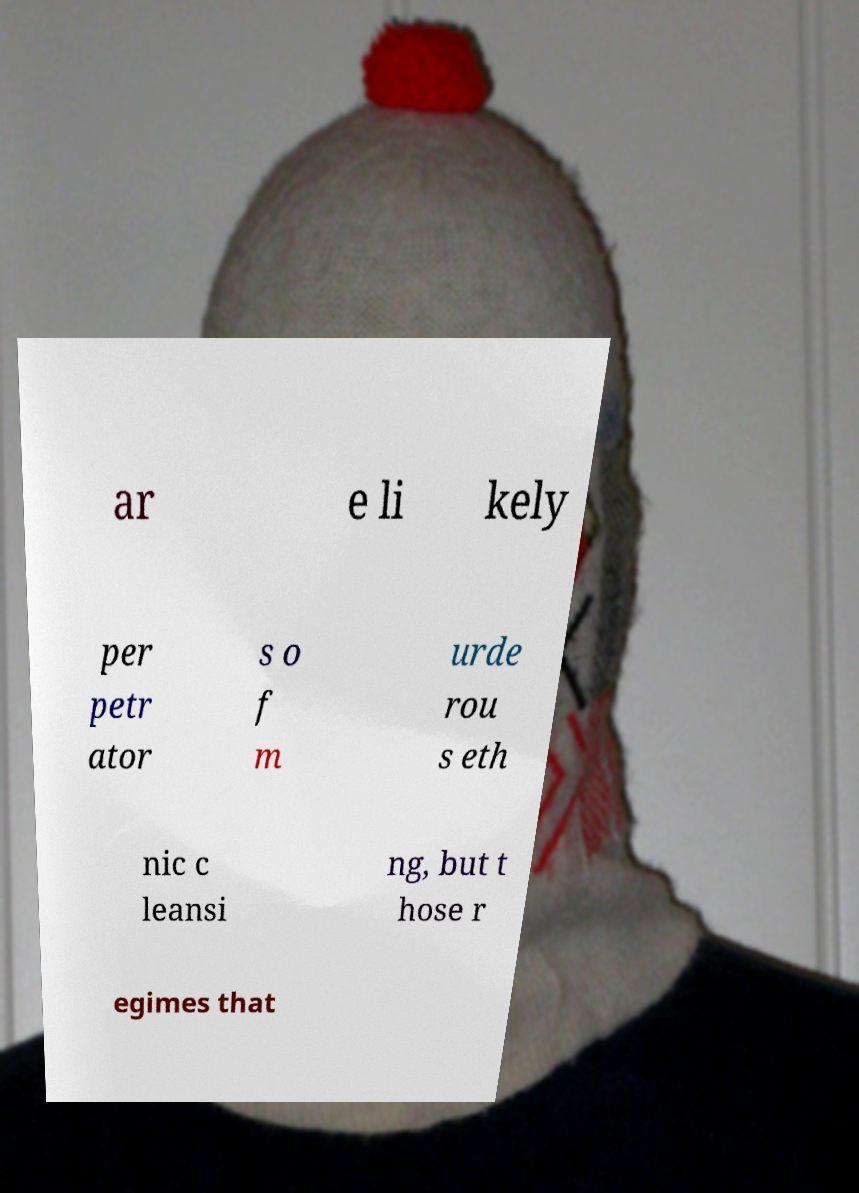Could you assist in decoding the text presented in this image and type it out clearly? ar e li kely per petr ator s o f m urde rou s eth nic c leansi ng, but t hose r egimes that 